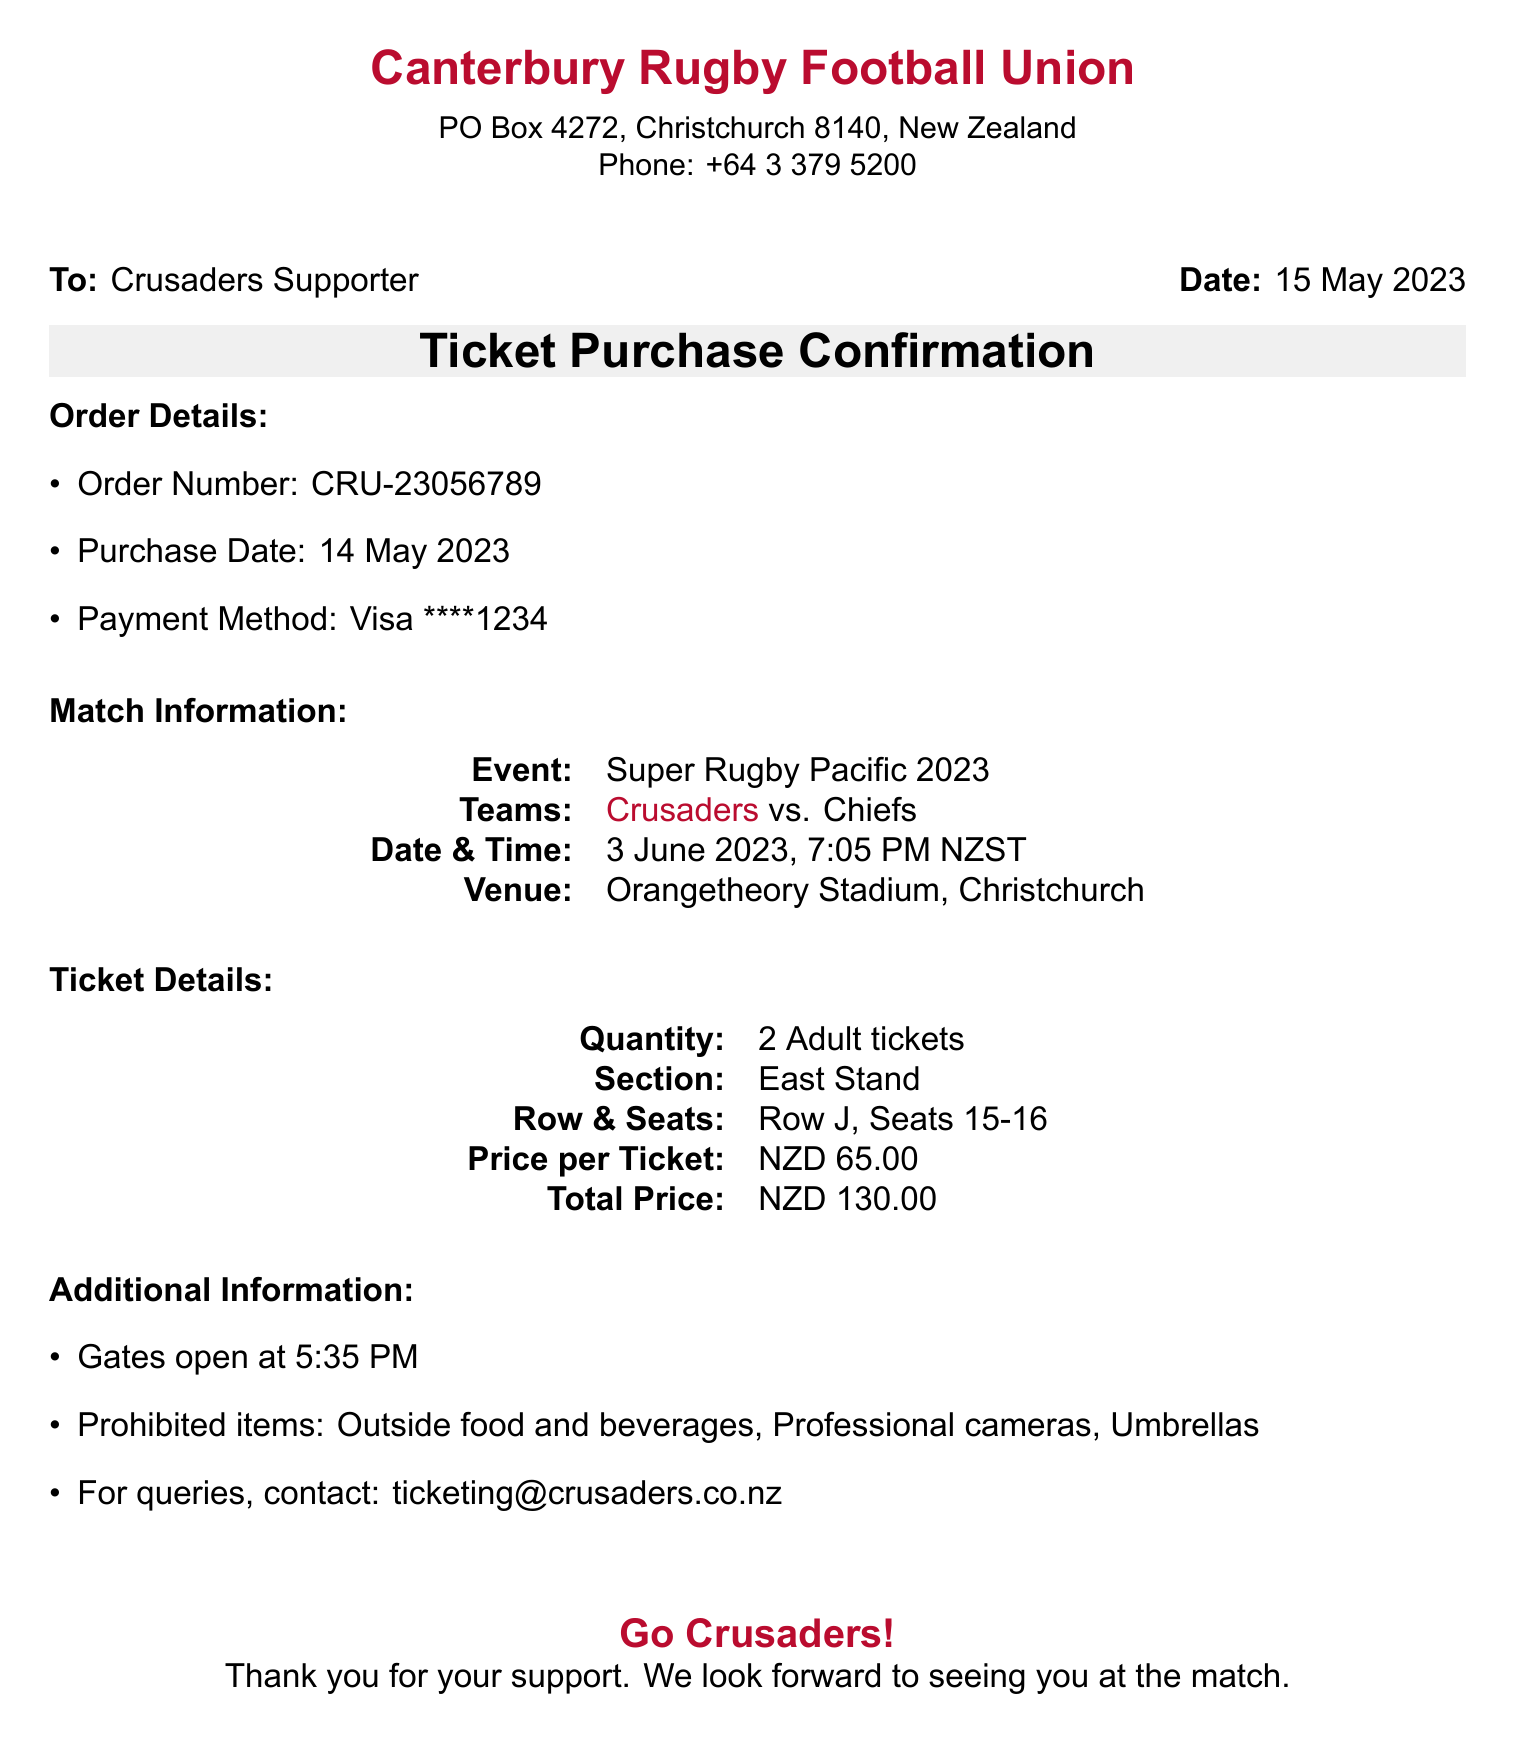What is the order number? The order number is specified in the order details section.
Answer: CRU-23056789 What event is being confirmed? The event is mentioned under the match information section.
Answer: Super Rugby Pacific 2023 When is the match scheduled? The date and time of the match are provided in the match information section.
Answer: 3 June 2023, 7:05 PM NZST How many tickets were purchased? The ticket quantity can be found in the ticket details section.
Answer: 2 Adult tickets What is the total price paid for the tickets? The total price is indicated in the ticket details section.
Answer: NZD 130.00 What section are the seats located in? The section information is found in the ticket details section.
Answer: East Stand What items are prohibited at the venue? Prohibited items are listed in the additional information section.
Answer: Outside food and beverages, Professional cameras, Umbrellas What is the email for ticketing queries? The contact email for queries is provided in the additional information section.
Answer: ticketing@crusaders.co.nz When do the gates open? The opening time of the gates is specified in the additional information segment.
Answer: 5:35 PM 